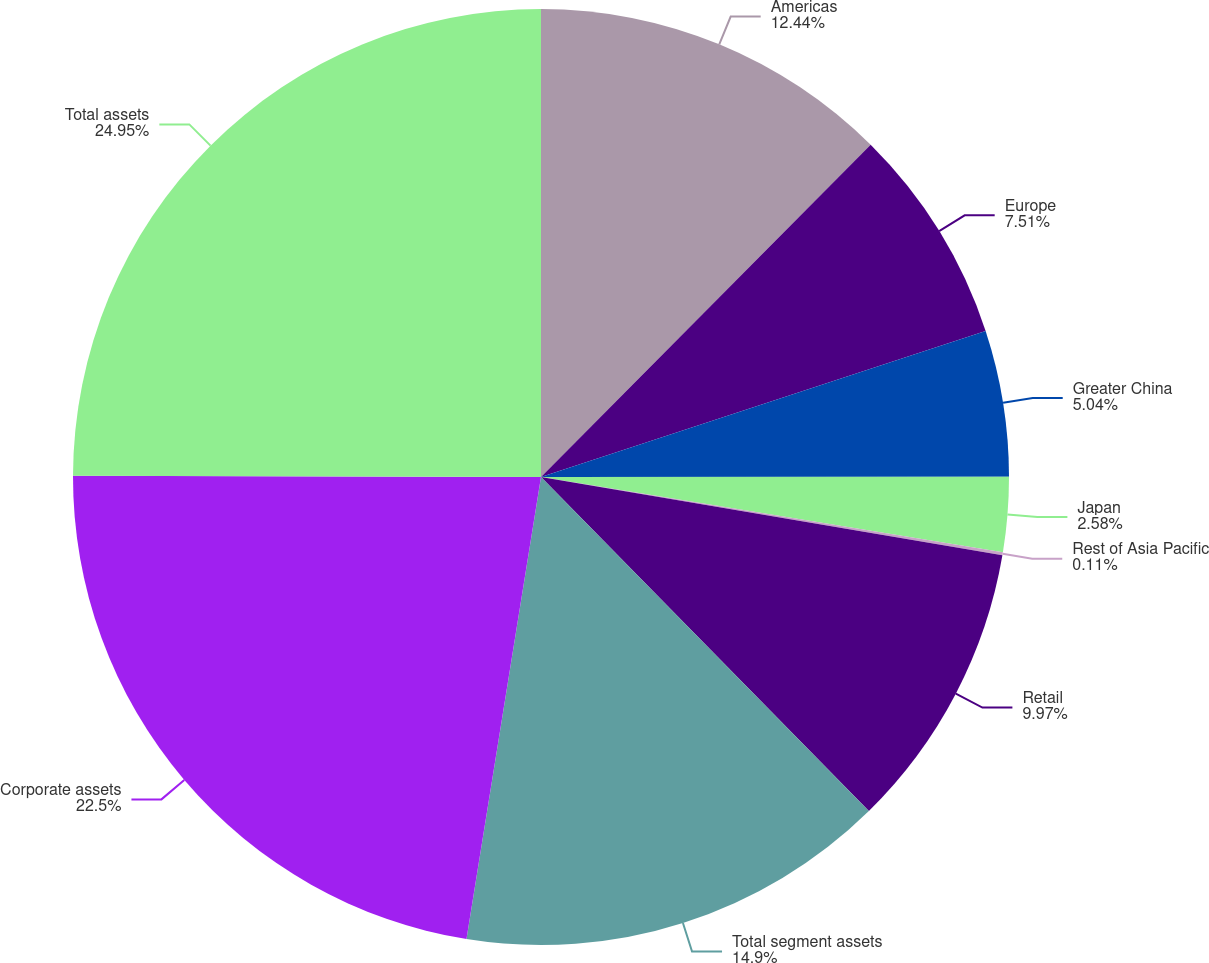Convert chart to OTSL. <chart><loc_0><loc_0><loc_500><loc_500><pie_chart><fcel>Americas<fcel>Europe<fcel>Greater China<fcel>Japan<fcel>Rest of Asia Pacific<fcel>Retail<fcel>Total segment assets<fcel>Corporate assets<fcel>Total assets<nl><fcel>12.44%<fcel>7.51%<fcel>5.04%<fcel>2.58%<fcel>0.11%<fcel>9.97%<fcel>14.9%<fcel>22.5%<fcel>24.96%<nl></chart> 